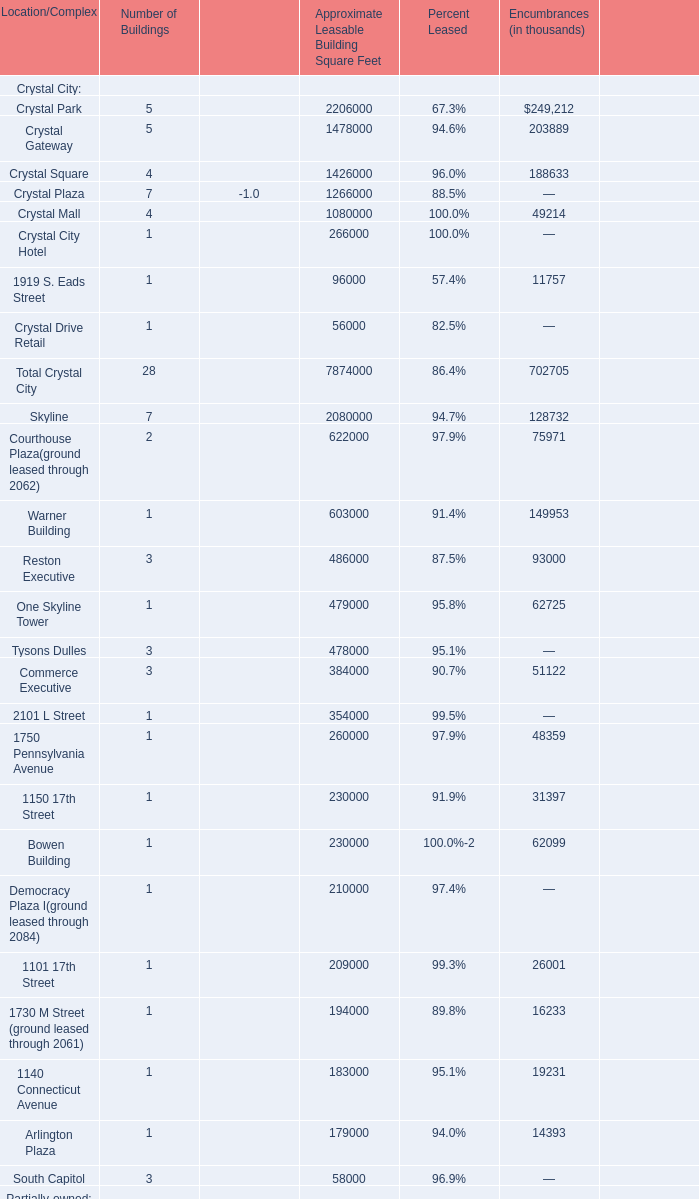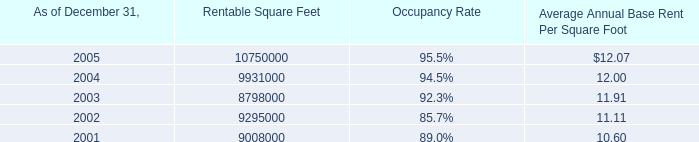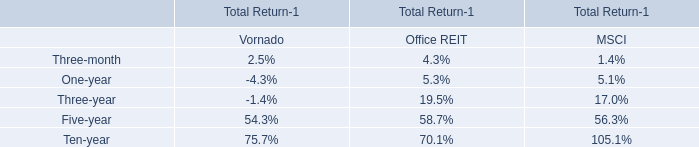for the the bergen mall in paramus , new jersey , approximately what percentage will be the square feet to be built by target on land leased from the company? 
Computations: (180000 / 1360000)
Answer: 0.13235. 